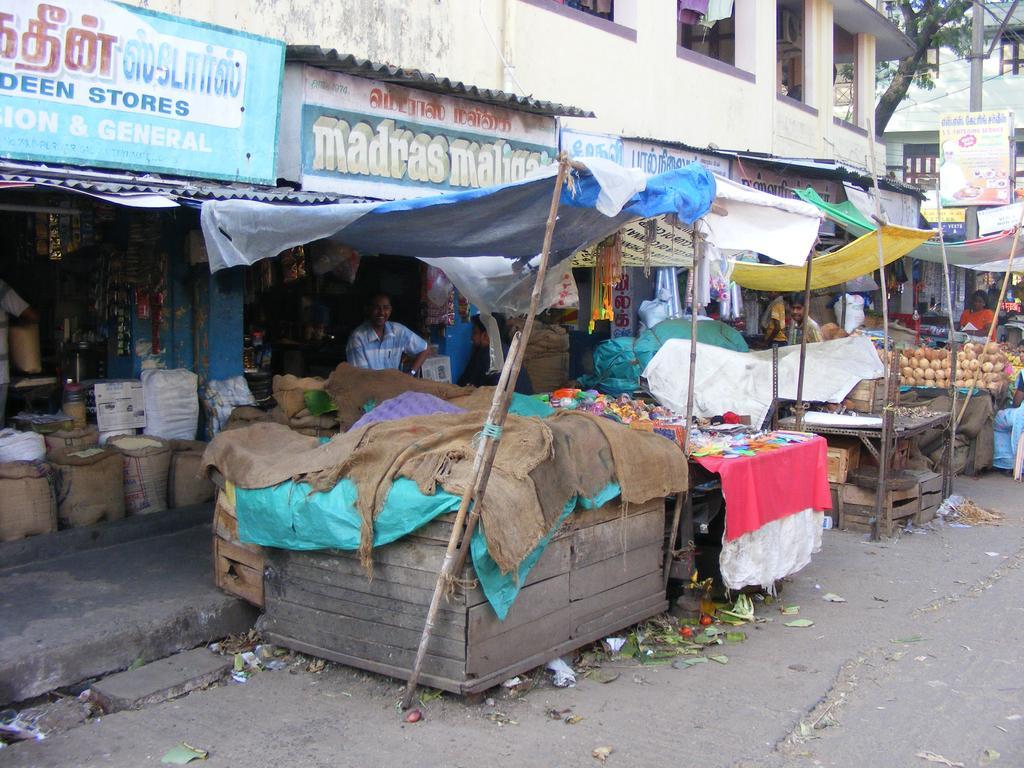Please provide a concise description of this image. In this image in the center there are stalls and there are tents. In the background there is a building and there are boards with some text written on it and there are shops, there is a tree and there is a pole with banner attached on the pole. 